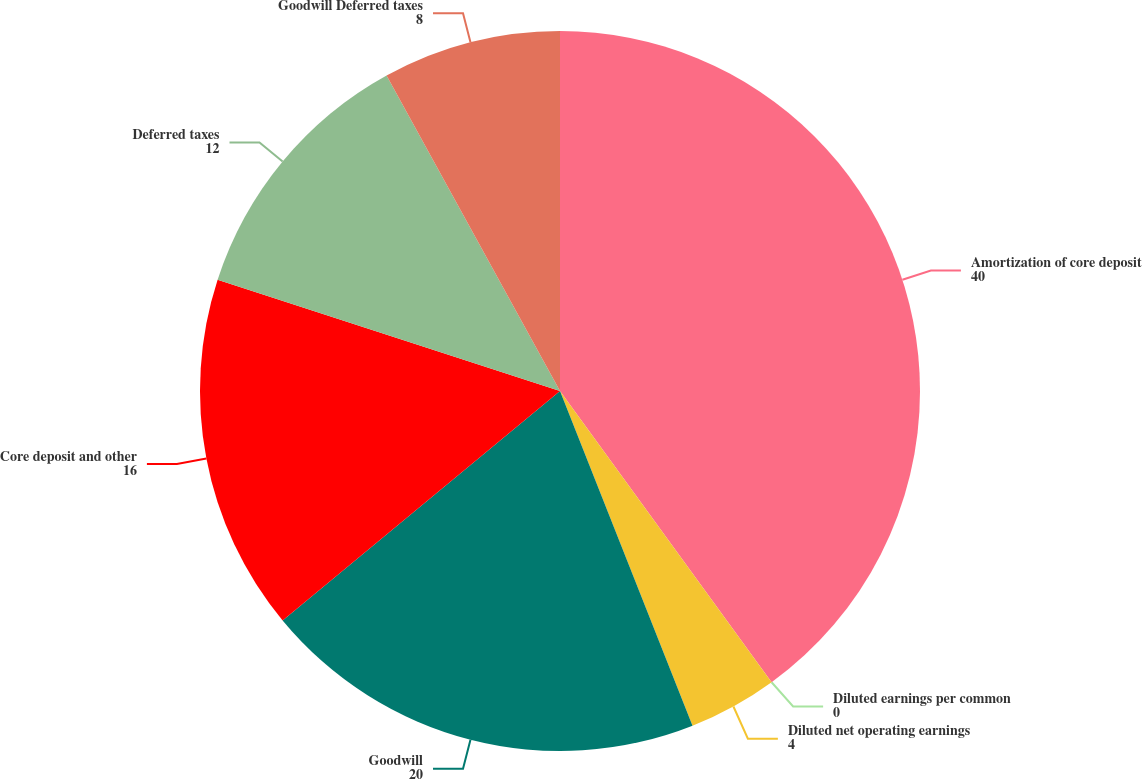<chart> <loc_0><loc_0><loc_500><loc_500><pie_chart><fcel>Amortization of core deposit<fcel>Diluted earnings per common<fcel>Diluted net operating earnings<fcel>Goodwill<fcel>Core deposit and other<fcel>Deferred taxes<fcel>Goodwill Deferred taxes<nl><fcel>40.0%<fcel>0.0%<fcel>4.0%<fcel>20.0%<fcel>16.0%<fcel>12.0%<fcel>8.0%<nl></chart> 